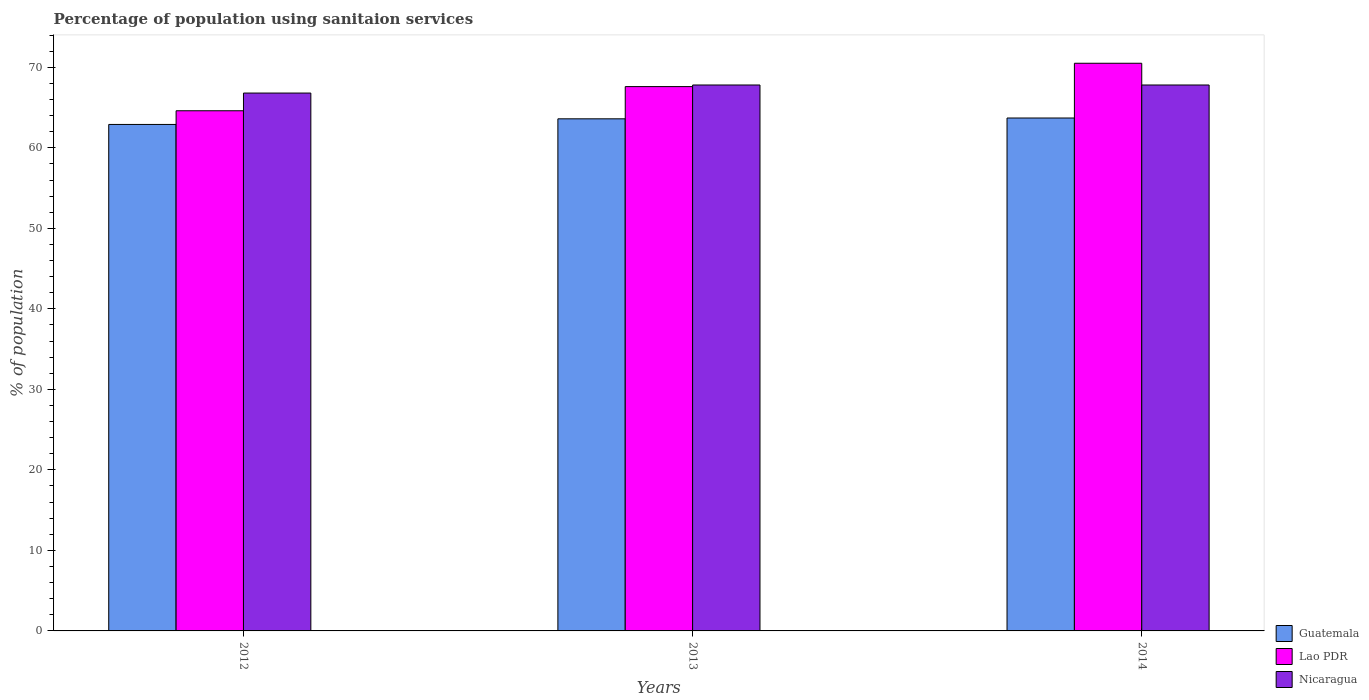How many different coloured bars are there?
Offer a terse response. 3. How many groups of bars are there?
Keep it short and to the point. 3. How many bars are there on the 2nd tick from the left?
Your response must be concise. 3. What is the label of the 2nd group of bars from the left?
Offer a terse response. 2013. What is the percentage of population using sanitaion services in Guatemala in 2012?
Keep it short and to the point. 62.9. Across all years, what is the maximum percentage of population using sanitaion services in Nicaragua?
Offer a terse response. 67.8. Across all years, what is the minimum percentage of population using sanitaion services in Lao PDR?
Give a very brief answer. 64.6. In which year was the percentage of population using sanitaion services in Guatemala minimum?
Provide a short and direct response. 2012. What is the total percentage of population using sanitaion services in Lao PDR in the graph?
Your answer should be compact. 202.7. What is the difference between the percentage of population using sanitaion services in Guatemala in 2014 and the percentage of population using sanitaion services in Nicaragua in 2013?
Make the answer very short. -4.1. What is the average percentage of population using sanitaion services in Nicaragua per year?
Your answer should be very brief. 67.47. In the year 2014, what is the difference between the percentage of population using sanitaion services in Nicaragua and percentage of population using sanitaion services in Guatemala?
Provide a short and direct response. 4.1. In how many years, is the percentage of population using sanitaion services in Nicaragua greater than 42 %?
Provide a succinct answer. 3. What is the ratio of the percentage of population using sanitaion services in Guatemala in 2012 to that in 2014?
Your answer should be compact. 0.99. Is the percentage of population using sanitaion services in Guatemala in 2012 less than that in 2013?
Offer a terse response. Yes. What is the difference between the highest and the second highest percentage of population using sanitaion services in Lao PDR?
Offer a very short reply. 2.9. What is the difference between the highest and the lowest percentage of population using sanitaion services in Lao PDR?
Provide a short and direct response. 5.9. What does the 3rd bar from the left in 2014 represents?
Ensure brevity in your answer.  Nicaragua. What does the 3rd bar from the right in 2014 represents?
Your answer should be compact. Guatemala. Are all the bars in the graph horizontal?
Offer a very short reply. No. How many years are there in the graph?
Ensure brevity in your answer.  3. What is the difference between two consecutive major ticks on the Y-axis?
Your answer should be very brief. 10. Are the values on the major ticks of Y-axis written in scientific E-notation?
Your response must be concise. No. Does the graph contain grids?
Offer a very short reply. No. How many legend labels are there?
Offer a very short reply. 3. What is the title of the graph?
Provide a short and direct response. Percentage of population using sanitaion services. Does "St. Vincent and the Grenadines" appear as one of the legend labels in the graph?
Make the answer very short. No. What is the label or title of the X-axis?
Offer a terse response. Years. What is the label or title of the Y-axis?
Give a very brief answer. % of population. What is the % of population of Guatemala in 2012?
Your answer should be compact. 62.9. What is the % of population in Lao PDR in 2012?
Ensure brevity in your answer.  64.6. What is the % of population in Nicaragua in 2012?
Offer a terse response. 66.8. What is the % of population in Guatemala in 2013?
Offer a very short reply. 63.6. What is the % of population of Lao PDR in 2013?
Provide a short and direct response. 67.6. What is the % of population in Nicaragua in 2013?
Offer a very short reply. 67.8. What is the % of population in Guatemala in 2014?
Offer a terse response. 63.7. What is the % of population of Lao PDR in 2014?
Your answer should be very brief. 70.5. What is the % of population of Nicaragua in 2014?
Offer a very short reply. 67.8. Across all years, what is the maximum % of population of Guatemala?
Your answer should be very brief. 63.7. Across all years, what is the maximum % of population of Lao PDR?
Your answer should be compact. 70.5. Across all years, what is the maximum % of population of Nicaragua?
Your answer should be compact. 67.8. Across all years, what is the minimum % of population of Guatemala?
Your response must be concise. 62.9. Across all years, what is the minimum % of population of Lao PDR?
Your answer should be compact. 64.6. Across all years, what is the minimum % of population of Nicaragua?
Your answer should be compact. 66.8. What is the total % of population in Guatemala in the graph?
Offer a very short reply. 190.2. What is the total % of population of Lao PDR in the graph?
Offer a very short reply. 202.7. What is the total % of population of Nicaragua in the graph?
Offer a terse response. 202.4. What is the difference between the % of population of Lao PDR in 2012 and that in 2013?
Offer a terse response. -3. What is the difference between the % of population in Nicaragua in 2012 and that in 2013?
Your response must be concise. -1. What is the difference between the % of population of Guatemala in 2013 and that in 2014?
Offer a very short reply. -0.1. What is the difference between the % of population in Nicaragua in 2013 and that in 2014?
Give a very brief answer. 0. What is the difference between the % of population of Guatemala in 2012 and the % of population of Nicaragua in 2013?
Provide a short and direct response. -4.9. What is the difference between the % of population of Guatemala in 2012 and the % of population of Lao PDR in 2014?
Offer a terse response. -7.6. What is the difference between the % of population of Lao PDR in 2012 and the % of population of Nicaragua in 2014?
Ensure brevity in your answer.  -3.2. What is the difference between the % of population in Guatemala in 2013 and the % of population in Lao PDR in 2014?
Keep it short and to the point. -6.9. What is the difference between the % of population in Guatemala in 2013 and the % of population in Nicaragua in 2014?
Ensure brevity in your answer.  -4.2. What is the average % of population in Guatemala per year?
Ensure brevity in your answer.  63.4. What is the average % of population of Lao PDR per year?
Ensure brevity in your answer.  67.57. What is the average % of population of Nicaragua per year?
Offer a terse response. 67.47. In the year 2012, what is the difference between the % of population in Guatemala and % of population in Nicaragua?
Your answer should be compact. -3.9. In the year 2012, what is the difference between the % of population of Lao PDR and % of population of Nicaragua?
Ensure brevity in your answer.  -2.2. In the year 2014, what is the difference between the % of population of Guatemala and % of population of Nicaragua?
Provide a short and direct response. -4.1. In the year 2014, what is the difference between the % of population of Lao PDR and % of population of Nicaragua?
Offer a terse response. 2.7. What is the ratio of the % of population of Lao PDR in 2012 to that in 2013?
Provide a short and direct response. 0.96. What is the ratio of the % of population in Guatemala in 2012 to that in 2014?
Give a very brief answer. 0.99. What is the ratio of the % of population of Lao PDR in 2012 to that in 2014?
Your answer should be very brief. 0.92. What is the ratio of the % of population of Lao PDR in 2013 to that in 2014?
Give a very brief answer. 0.96. What is the ratio of the % of population of Nicaragua in 2013 to that in 2014?
Provide a short and direct response. 1. What is the difference between the highest and the lowest % of population in Guatemala?
Your answer should be very brief. 0.8. 